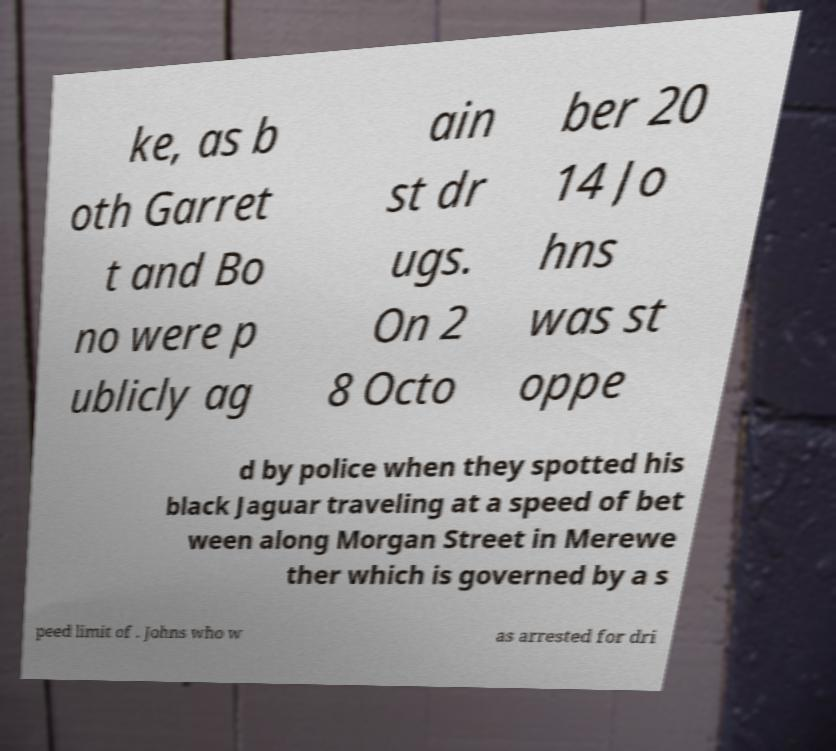Can you accurately transcribe the text from the provided image for me? ke, as b oth Garret t and Bo no were p ublicly ag ain st dr ugs. On 2 8 Octo ber 20 14 Jo hns was st oppe d by police when they spotted his black Jaguar traveling at a speed of bet ween along Morgan Street in Merewe ther which is governed by a s peed limit of . Johns who w as arrested for dri 